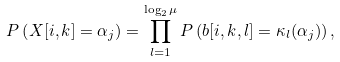<formula> <loc_0><loc_0><loc_500><loc_500>P \left ( X [ i , k ] = \alpha _ { j } \right ) = \prod _ { l = 1 } ^ { \log _ { 2 } \mu } P \left ( b [ i , k , l ] = \kappa _ { l } ( \alpha _ { j } ) \right ) ,</formula> 